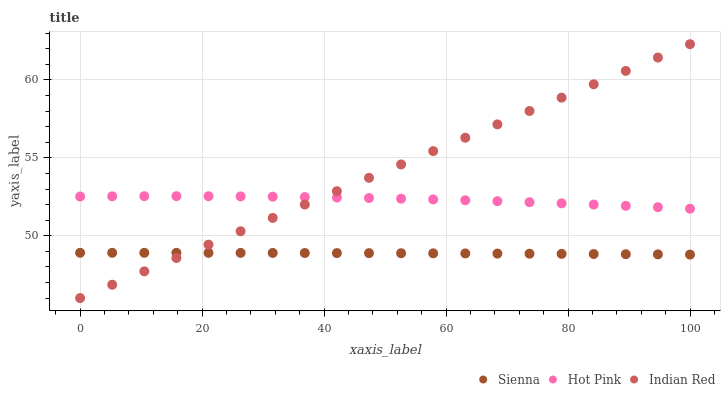Does Sienna have the minimum area under the curve?
Answer yes or no. Yes. Does Indian Red have the maximum area under the curve?
Answer yes or no. Yes. Does Hot Pink have the minimum area under the curve?
Answer yes or no. No. Does Hot Pink have the maximum area under the curve?
Answer yes or no. No. Is Indian Red the smoothest?
Answer yes or no. Yes. Is Hot Pink the roughest?
Answer yes or no. Yes. Is Hot Pink the smoothest?
Answer yes or no. No. Is Indian Red the roughest?
Answer yes or no. No. Does Indian Red have the lowest value?
Answer yes or no. Yes. Does Hot Pink have the lowest value?
Answer yes or no. No. Does Indian Red have the highest value?
Answer yes or no. Yes. Does Hot Pink have the highest value?
Answer yes or no. No. Is Sienna less than Hot Pink?
Answer yes or no. Yes. Is Hot Pink greater than Sienna?
Answer yes or no. Yes. Does Indian Red intersect Sienna?
Answer yes or no. Yes. Is Indian Red less than Sienna?
Answer yes or no. No. Is Indian Red greater than Sienna?
Answer yes or no. No. Does Sienna intersect Hot Pink?
Answer yes or no. No. 